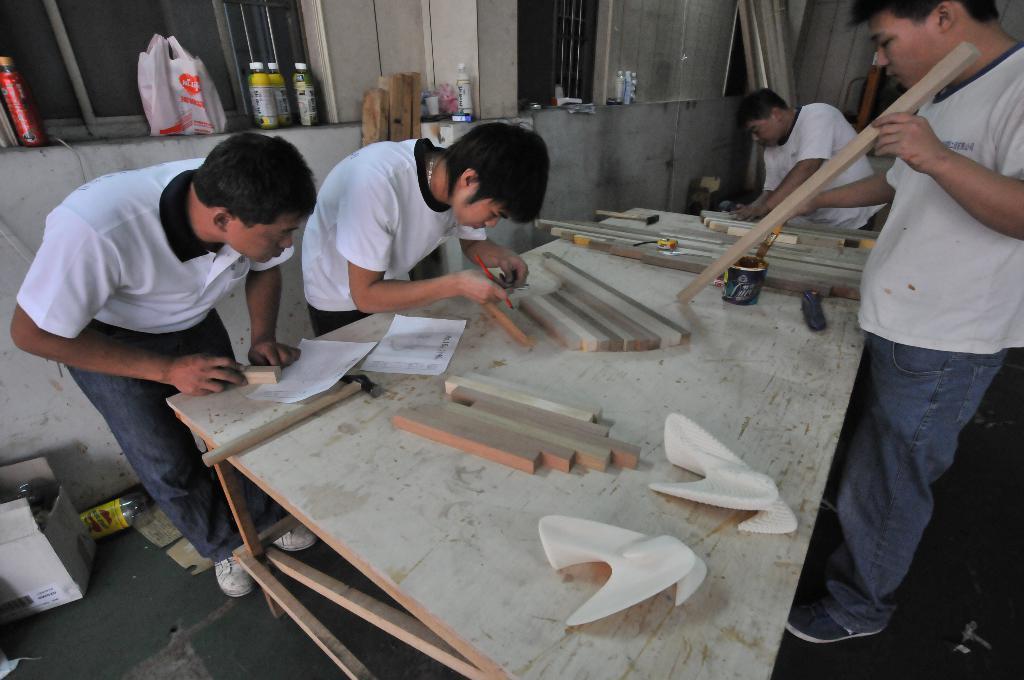In one or two sentences, can you explain what this image depicts? In the image there are total four people wearing white color t-shirt and working with the wood, in front of them there is a table on which the wooden bars placed in the background there is a white color wall and also a window where beside the window there are some bottles and the cover is placed. 